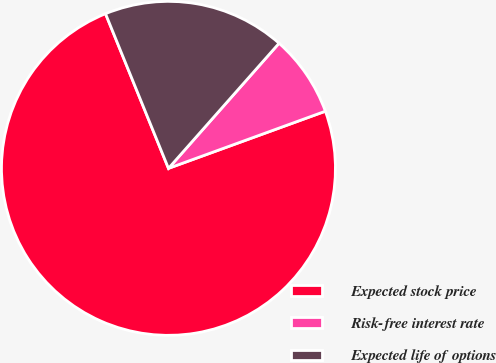<chart> <loc_0><loc_0><loc_500><loc_500><pie_chart><fcel>Expected stock price<fcel>Risk-free interest rate<fcel>Expected life of options<nl><fcel>74.4%<fcel>7.92%<fcel>17.67%<nl></chart> 